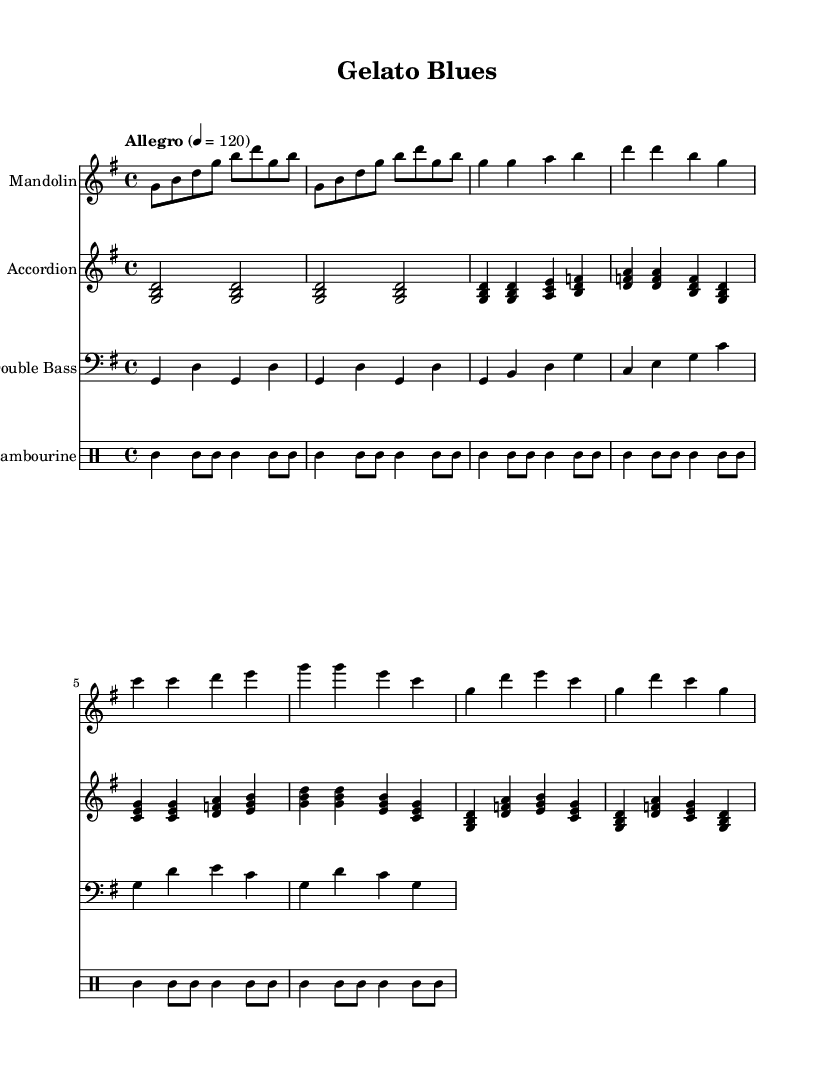What is the key signature of this music? The key signature is G major, which has one sharp (F#). This can be determined by looking at the clef sign and the key signature indicated at the beginning of the staff.
Answer: G major What is the time signature of this music? The time signature is 4/4, indicating four beats in each measure, and the quarter note gets one beat. This is stated at the beginning of the score.
Answer: 4/4 What is the tempo marking for this piece? The tempo marking indicates "Allegro" at a speed of 120 beats per minute. This is directly noted in the tempo indication at the beginning of the score.
Answer: Allegro, 120 Which instrument plays the main melody? The mandolin plays the main melody, as its notes are more prominent and fit the lead role in the arrangement compared to the accompaniment instruments.
Answer: Mandolin How many measures are in the intro section? The intro section consists of 2 measures, as indicated in the music notation which shows repeated phrases for that part.
Answer: 2 measures What is the role of the tambourine in this composition? The tambourine serves as a rhythmic accompaniment, providing consistent beats and enhancing the overall bluesy feel with a typical shuffle rhythm. This can be inferred from its repetitive pattern throughout the sections.
Answer: Rhythmic accompaniment Which section includes the highest pitch notes? The chorus section includes the highest pitch notes, particularly in the parts where the mandolin plays, showing higher note ranges compared to other sections.
Answer: Chorus 